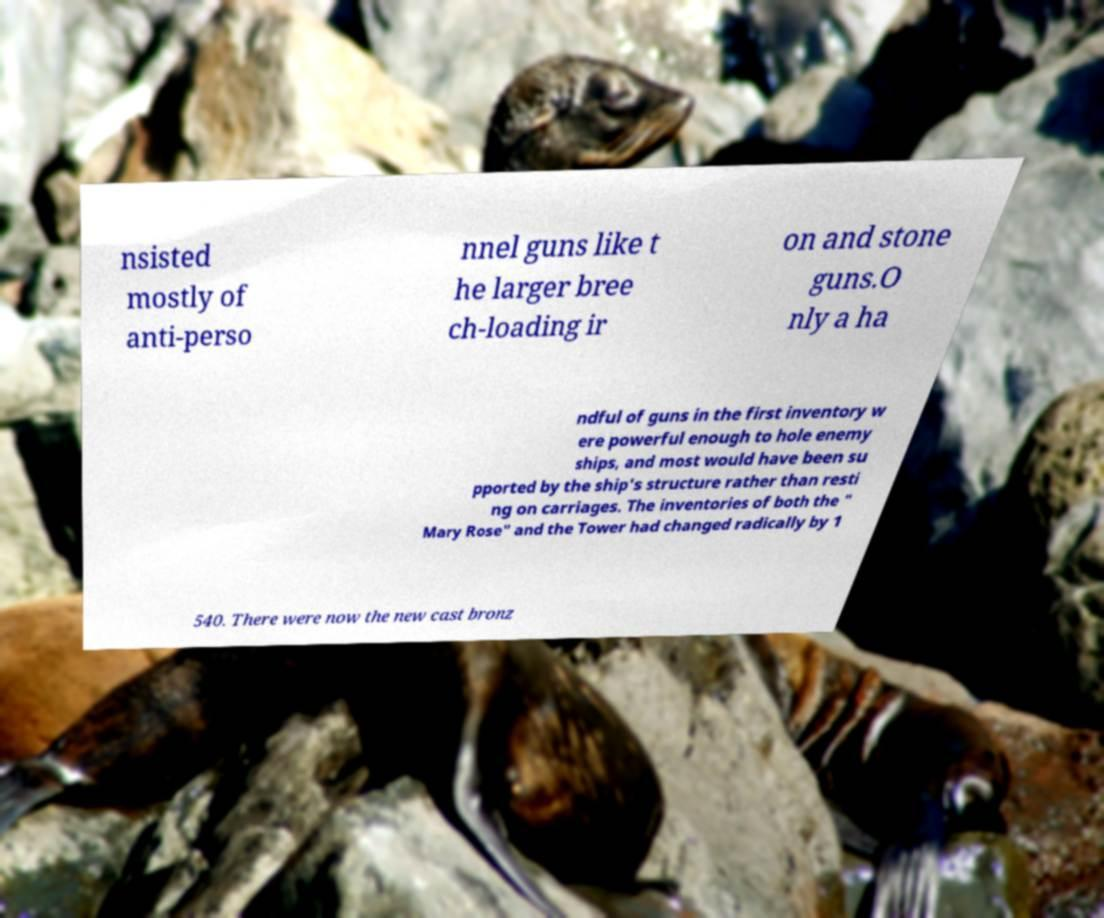Please read and relay the text visible in this image. What does it say? nsisted mostly of anti-perso nnel guns like t he larger bree ch-loading ir on and stone guns.O nly a ha ndful of guns in the first inventory w ere powerful enough to hole enemy ships, and most would have been su pported by the ship's structure rather than resti ng on carriages. The inventories of both the " Mary Rose" and the Tower had changed radically by 1 540. There were now the new cast bronz 